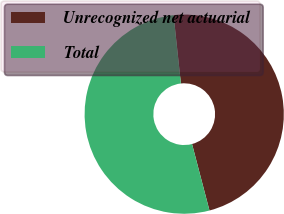<chart> <loc_0><loc_0><loc_500><loc_500><pie_chart><fcel>Unrecognized net actuarial<fcel>Total<nl><fcel>47.62%<fcel>52.38%<nl></chart> 